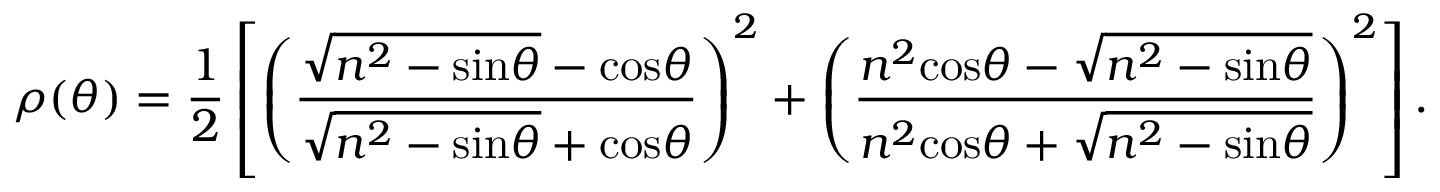<formula> <loc_0><loc_0><loc_500><loc_500>\rho ( \theta ) = \frac { 1 } { 2 } \left [ \left ( \frac { \sqrt { n ^ { 2 } - \sin \theta } - \cos \theta } { \sqrt { n ^ { 2 } - \sin \theta } + \cos \theta } \right ) ^ { 2 } + \left ( \frac { n ^ { 2 } \cos \theta - \sqrt { n ^ { 2 } - \sin \theta } } { n ^ { 2 } \cos \theta + \sqrt { n ^ { 2 } - \sin \theta } } \right ) ^ { 2 } \right ] .</formula> 